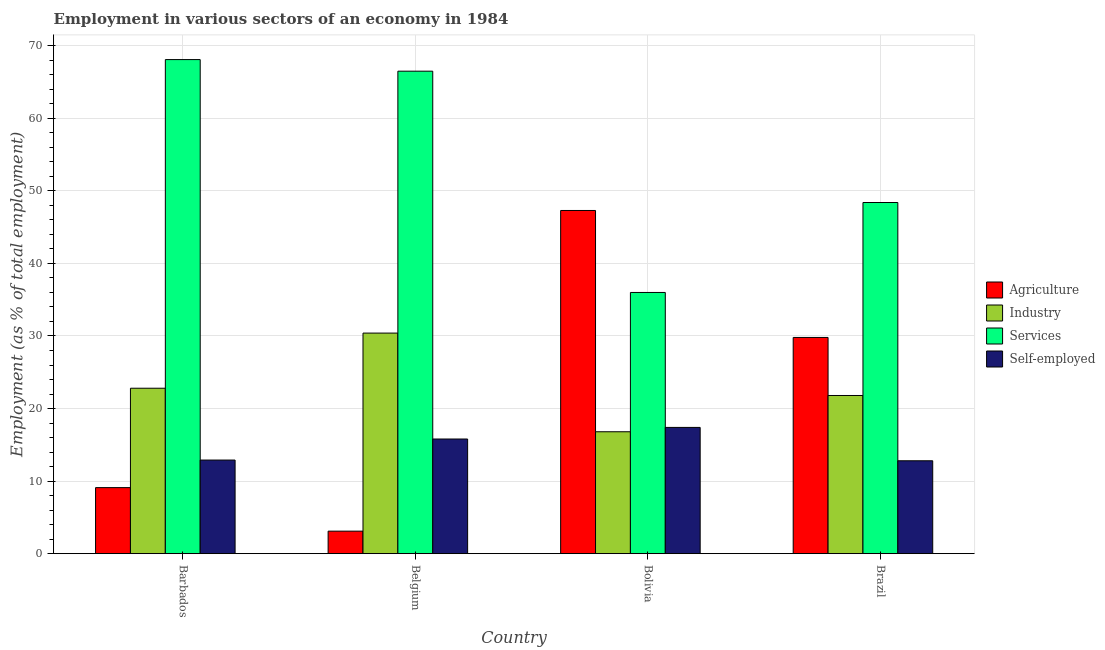How many groups of bars are there?
Give a very brief answer. 4. Are the number of bars per tick equal to the number of legend labels?
Provide a short and direct response. Yes. What is the label of the 3rd group of bars from the left?
Your answer should be very brief. Bolivia. In how many cases, is the number of bars for a given country not equal to the number of legend labels?
Make the answer very short. 0. What is the percentage of self employed workers in Bolivia?
Ensure brevity in your answer.  17.4. Across all countries, what is the maximum percentage of workers in industry?
Your answer should be compact. 30.4. In which country was the percentage of workers in agriculture minimum?
Your answer should be very brief. Belgium. What is the total percentage of workers in agriculture in the graph?
Provide a short and direct response. 89.3. What is the difference between the percentage of workers in industry in Barbados and that in Belgium?
Your answer should be very brief. -7.6. What is the difference between the percentage of workers in industry in Belgium and the percentage of workers in services in Barbados?
Give a very brief answer. -37.7. What is the average percentage of workers in agriculture per country?
Offer a very short reply. 22.32. What is the difference between the percentage of workers in agriculture and percentage of workers in services in Barbados?
Ensure brevity in your answer.  -59. In how many countries, is the percentage of self employed workers greater than 18 %?
Make the answer very short. 0. What is the ratio of the percentage of workers in industry in Bolivia to that in Brazil?
Provide a short and direct response. 0.77. Is the difference between the percentage of workers in agriculture in Bolivia and Brazil greater than the difference between the percentage of workers in industry in Bolivia and Brazil?
Offer a terse response. Yes. What is the difference between the highest and the second highest percentage of workers in agriculture?
Your response must be concise. 17.5. What is the difference between the highest and the lowest percentage of workers in industry?
Offer a terse response. 13.6. In how many countries, is the percentage of self employed workers greater than the average percentage of self employed workers taken over all countries?
Ensure brevity in your answer.  2. Is it the case that in every country, the sum of the percentage of workers in agriculture and percentage of workers in industry is greater than the sum of percentage of workers in services and percentage of self employed workers?
Offer a terse response. No. What does the 1st bar from the left in Barbados represents?
Give a very brief answer. Agriculture. What does the 1st bar from the right in Bolivia represents?
Your response must be concise. Self-employed. How many bars are there?
Offer a terse response. 16. How many countries are there in the graph?
Ensure brevity in your answer.  4. How are the legend labels stacked?
Give a very brief answer. Vertical. What is the title of the graph?
Your response must be concise. Employment in various sectors of an economy in 1984. What is the label or title of the Y-axis?
Keep it short and to the point. Employment (as % of total employment). What is the Employment (as % of total employment) of Agriculture in Barbados?
Your response must be concise. 9.1. What is the Employment (as % of total employment) in Industry in Barbados?
Ensure brevity in your answer.  22.8. What is the Employment (as % of total employment) in Services in Barbados?
Provide a short and direct response. 68.1. What is the Employment (as % of total employment) of Self-employed in Barbados?
Make the answer very short. 12.9. What is the Employment (as % of total employment) in Agriculture in Belgium?
Keep it short and to the point. 3.1. What is the Employment (as % of total employment) in Industry in Belgium?
Provide a short and direct response. 30.4. What is the Employment (as % of total employment) of Services in Belgium?
Your response must be concise. 66.5. What is the Employment (as % of total employment) of Self-employed in Belgium?
Keep it short and to the point. 15.8. What is the Employment (as % of total employment) in Agriculture in Bolivia?
Ensure brevity in your answer.  47.3. What is the Employment (as % of total employment) of Industry in Bolivia?
Provide a succinct answer. 16.8. What is the Employment (as % of total employment) of Self-employed in Bolivia?
Give a very brief answer. 17.4. What is the Employment (as % of total employment) of Agriculture in Brazil?
Offer a terse response. 29.8. What is the Employment (as % of total employment) of Industry in Brazil?
Make the answer very short. 21.8. What is the Employment (as % of total employment) of Services in Brazil?
Provide a short and direct response. 48.4. What is the Employment (as % of total employment) in Self-employed in Brazil?
Offer a terse response. 12.8. Across all countries, what is the maximum Employment (as % of total employment) in Agriculture?
Provide a succinct answer. 47.3. Across all countries, what is the maximum Employment (as % of total employment) in Industry?
Provide a short and direct response. 30.4. Across all countries, what is the maximum Employment (as % of total employment) in Services?
Offer a very short reply. 68.1. Across all countries, what is the maximum Employment (as % of total employment) in Self-employed?
Make the answer very short. 17.4. Across all countries, what is the minimum Employment (as % of total employment) in Agriculture?
Provide a succinct answer. 3.1. Across all countries, what is the minimum Employment (as % of total employment) in Industry?
Provide a succinct answer. 16.8. Across all countries, what is the minimum Employment (as % of total employment) of Services?
Offer a very short reply. 36. Across all countries, what is the minimum Employment (as % of total employment) in Self-employed?
Your answer should be very brief. 12.8. What is the total Employment (as % of total employment) of Agriculture in the graph?
Offer a terse response. 89.3. What is the total Employment (as % of total employment) in Industry in the graph?
Keep it short and to the point. 91.8. What is the total Employment (as % of total employment) of Services in the graph?
Make the answer very short. 219. What is the total Employment (as % of total employment) in Self-employed in the graph?
Your answer should be compact. 58.9. What is the difference between the Employment (as % of total employment) in Industry in Barbados and that in Belgium?
Your answer should be very brief. -7.6. What is the difference between the Employment (as % of total employment) in Self-employed in Barbados and that in Belgium?
Ensure brevity in your answer.  -2.9. What is the difference between the Employment (as % of total employment) of Agriculture in Barbados and that in Bolivia?
Your answer should be very brief. -38.2. What is the difference between the Employment (as % of total employment) of Services in Barbados and that in Bolivia?
Offer a very short reply. 32.1. What is the difference between the Employment (as % of total employment) in Agriculture in Barbados and that in Brazil?
Make the answer very short. -20.7. What is the difference between the Employment (as % of total employment) in Agriculture in Belgium and that in Bolivia?
Your answer should be compact. -44.2. What is the difference between the Employment (as % of total employment) in Industry in Belgium and that in Bolivia?
Offer a very short reply. 13.6. What is the difference between the Employment (as % of total employment) in Services in Belgium and that in Bolivia?
Make the answer very short. 30.5. What is the difference between the Employment (as % of total employment) in Self-employed in Belgium and that in Bolivia?
Make the answer very short. -1.6. What is the difference between the Employment (as % of total employment) of Agriculture in Belgium and that in Brazil?
Your response must be concise. -26.7. What is the difference between the Employment (as % of total employment) in Industry in Belgium and that in Brazil?
Your answer should be compact. 8.6. What is the difference between the Employment (as % of total employment) of Industry in Bolivia and that in Brazil?
Provide a short and direct response. -5. What is the difference between the Employment (as % of total employment) of Services in Bolivia and that in Brazil?
Ensure brevity in your answer.  -12.4. What is the difference between the Employment (as % of total employment) of Self-employed in Bolivia and that in Brazil?
Offer a terse response. 4.6. What is the difference between the Employment (as % of total employment) in Agriculture in Barbados and the Employment (as % of total employment) in Industry in Belgium?
Provide a succinct answer. -21.3. What is the difference between the Employment (as % of total employment) in Agriculture in Barbados and the Employment (as % of total employment) in Services in Belgium?
Offer a terse response. -57.4. What is the difference between the Employment (as % of total employment) of Industry in Barbados and the Employment (as % of total employment) of Services in Belgium?
Provide a succinct answer. -43.7. What is the difference between the Employment (as % of total employment) in Services in Barbados and the Employment (as % of total employment) in Self-employed in Belgium?
Give a very brief answer. 52.3. What is the difference between the Employment (as % of total employment) in Agriculture in Barbados and the Employment (as % of total employment) in Services in Bolivia?
Your answer should be very brief. -26.9. What is the difference between the Employment (as % of total employment) of Agriculture in Barbados and the Employment (as % of total employment) of Self-employed in Bolivia?
Give a very brief answer. -8.3. What is the difference between the Employment (as % of total employment) of Industry in Barbados and the Employment (as % of total employment) of Self-employed in Bolivia?
Make the answer very short. 5.4. What is the difference between the Employment (as % of total employment) of Services in Barbados and the Employment (as % of total employment) of Self-employed in Bolivia?
Your response must be concise. 50.7. What is the difference between the Employment (as % of total employment) in Agriculture in Barbados and the Employment (as % of total employment) in Industry in Brazil?
Your answer should be compact. -12.7. What is the difference between the Employment (as % of total employment) of Agriculture in Barbados and the Employment (as % of total employment) of Services in Brazil?
Your answer should be very brief. -39.3. What is the difference between the Employment (as % of total employment) in Industry in Barbados and the Employment (as % of total employment) in Services in Brazil?
Give a very brief answer. -25.6. What is the difference between the Employment (as % of total employment) of Industry in Barbados and the Employment (as % of total employment) of Self-employed in Brazil?
Your answer should be compact. 10. What is the difference between the Employment (as % of total employment) of Services in Barbados and the Employment (as % of total employment) of Self-employed in Brazil?
Keep it short and to the point. 55.3. What is the difference between the Employment (as % of total employment) in Agriculture in Belgium and the Employment (as % of total employment) in Industry in Bolivia?
Your answer should be very brief. -13.7. What is the difference between the Employment (as % of total employment) of Agriculture in Belgium and the Employment (as % of total employment) of Services in Bolivia?
Offer a terse response. -32.9. What is the difference between the Employment (as % of total employment) in Agriculture in Belgium and the Employment (as % of total employment) in Self-employed in Bolivia?
Provide a short and direct response. -14.3. What is the difference between the Employment (as % of total employment) of Industry in Belgium and the Employment (as % of total employment) of Self-employed in Bolivia?
Ensure brevity in your answer.  13. What is the difference between the Employment (as % of total employment) in Services in Belgium and the Employment (as % of total employment) in Self-employed in Bolivia?
Offer a terse response. 49.1. What is the difference between the Employment (as % of total employment) of Agriculture in Belgium and the Employment (as % of total employment) of Industry in Brazil?
Keep it short and to the point. -18.7. What is the difference between the Employment (as % of total employment) in Agriculture in Belgium and the Employment (as % of total employment) in Services in Brazil?
Offer a terse response. -45.3. What is the difference between the Employment (as % of total employment) in Agriculture in Belgium and the Employment (as % of total employment) in Self-employed in Brazil?
Offer a terse response. -9.7. What is the difference between the Employment (as % of total employment) in Industry in Belgium and the Employment (as % of total employment) in Self-employed in Brazil?
Give a very brief answer. 17.6. What is the difference between the Employment (as % of total employment) of Services in Belgium and the Employment (as % of total employment) of Self-employed in Brazil?
Ensure brevity in your answer.  53.7. What is the difference between the Employment (as % of total employment) in Agriculture in Bolivia and the Employment (as % of total employment) in Services in Brazil?
Provide a short and direct response. -1.1. What is the difference between the Employment (as % of total employment) in Agriculture in Bolivia and the Employment (as % of total employment) in Self-employed in Brazil?
Keep it short and to the point. 34.5. What is the difference between the Employment (as % of total employment) in Industry in Bolivia and the Employment (as % of total employment) in Services in Brazil?
Keep it short and to the point. -31.6. What is the difference between the Employment (as % of total employment) of Services in Bolivia and the Employment (as % of total employment) of Self-employed in Brazil?
Offer a very short reply. 23.2. What is the average Employment (as % of total employment) in Agriculture per country?
Your answer should be compact. 22.32. What is the average Employment (as % of total employment) in Industry per country?
Your answer should be very brief. 22.95. What is the average Employment (as % of total employment) of Services per country?
Your answer should be compact. 54.75. What is the average Employment (as % of total employment) in Self-employed per country?
Ensure brevity in your answer.  14.72. What is the difference between the Employment (as % of total employment) of Agriculture and Employment (as % of total employment) of Industry in Barbados?
Your answer should be very brief. -13.7. What is the difference between the Employment (as % of total employment) of Agriculture and Employment (as % of total employment) of Services in Barbados?
Your answer should be very brief. -59. What is the difference between the Employment (as % of total employment) in Industry and Employment (as % of total employment) in Services in Barbados?
Provide a succinct answer. -45.3. What is the difference between the Employment (as % of total employment) of Services and Employment (as % of total employment) of Self-employed in Barbados?
Keep it short and to the point. 55.2. What is the difference between the Employment (as % of total employment) in Agriculture and Employment (as % of total employment) in Industry in Belgium?
Make the answer very short. -27.3. What is the difference between the Employment (as % of total employment) of Agriculture and Employment (as % of total employment) of Services in Belgium?
Offer a very short reply. -63.4. What is the difference between the Employment (as % of total employment) in Industry and Employment (as % of total employment) in Services in Belgium?
Give a very brief answer. -36.1. What is the difference between the Employment (as % of total employment) of Industry and Employment (as % of total employment) of Self-employed in Belgium?
Your answer should be compact. 14.6. What is the difference between the Employment (as % of total employment) in Services and Employment (as % of total employment) in Self-employed in Belgium?
Provide a succinct answer. 50.7. What is the difference between the Employment (as % of total employment) of Agriculture and Employment (as % of total employment) of Industry in Bolivia?
Your answer should be very brief. 30.5. What is the difference between the Employment (as % of total employment) of Agriculture and Employment (as % of total employment) of Self-employed in Bolivia?
Keep it short and to the point. 29.9. What is the difference between the Employment (as % of total employment) of Industry and Employment (as % of total employment) of Services in Bolivia?
Your answer should be very brief. -19.2. What is the difference between the Employment (as % of total employment) in Services and Employment (as % of total employment) in Self-employed in Bolivia?
Provide a succinct answer. 18.6. What is the difference between the Employment (as % of total employment) in Agriculture and Employment (as % of total employment) in Services in Brazil?
Offer a very short reply. -18.6. What is the difference between the Employment (as % of total employment) of Agriculture and Employment (as % of total employment) of Self-employed in Brazil?
Offer a terse response. 17. What is the difference between the Employment (as % of total employment) in Industry and Employment (as % of total employment) in Services in Brazil?
Provide a short and direct response. -26.6. What is the difference between the Employment (as % of total employment) of Services and Employment (as % of total employment) of Self-employed in Brazil?
Provide a short and direct response. 35.6. What is the ratio of the Employment (as % of total employment) of Agriculture in Barbados to that in Belgium?
Your answer should be compact. 2.94. What is the ratio of the Employment (as % of total employment) in Industry in Barbados to that in Belgium?
Your response must be concise. 0.75. What is the ratio of the Employment (as % of total employment) in Services in Barbados to that in Belgium?
Offer a very short reply. 1.02. What is the ratio of the Employment (as % of total employment) of Self-employed in Barbados to that in Belgium?
Give a very brief answer. 0.82. What is the ratio of the Employment (as % of total employment) of Agriculture in Barbados to that in Bolivia?
Your answer should be very brief. 0.19. What is the ratio of the Employment (as % of total employment) of Industry in Barbados to that in Bolivia?
Provide a succinct answer. 1.36. What is the ratio of the Employment (as % of total employment) of Services in Barbados to that in Bolivia?
Provide a short and direct response. 1.89. What is the ratio of the Employment (as % of total employment) in Self-employed in Barbados to that in Bolivia?
Offer a terse response. 0.74. What is the ratio of the Employment (as % of total employment) in Agriculture in Barbados to that in Brazil?
Offer a terse response. 0.31. What is the ratio of the Employment (as % of total employment) of Industry in Barbados to that in Brazil?
Offer a very short reply. 1.05. What is the ratio of the Employment (as % of total employment) of Services in Barbados to that in Brazil?
Your response must be concise. 1.41. What is the ratio of the Employment (as % of total employment) in Agriculture in Belgium to that in Bolivia?
Provide a succinct answer. 0.07. What is the ratio of the Employment (as % of total employment) in Industry in Belgium to that in Bolivia?
Provide a succinct answer. 1.81. What is the ratio of the Employment (as % of total employment) of Services in Belgium to that in Bolivia?
Offer a very short reply. 1.85. What is the ratio of the Employment (as % of total employment) in Self-employed in Belgium to that in Bolivia?
Keep it short and to the point. 0.91. What is the ratio of the Employment (as % of total employment) of Agriculture in Belgium to that in Brazil?
Offer a terse response. 0.1. What is the ratio of the Employment (as % of total employment) of Industry in Belgium to that in Brazil?
Provide a short and direct response. 1.39. What is the ratio of the Employment (as % of total employment) of Services in Belgium to that in Brazil?
Your response must be concise. 1.37. What is the ratio of the Employment (as % of total employment) in Self-employed in Belgium to that in Brazil?
Make the answer very short. 1.23. What is the ratio of the Employment (as % of total employment) in Agriculture in Bolivia to that in Brazil?
Offer a very short reply. 1.59. What is the ratio of the Employment (as % of total employment) in Industry in Bolivia to that in Brazil?
Keep it short and to the point. 0.77. What is the ratio of the Employment (as % of total employment) of Services in Bolivia to that in Brazil?
Your answer should be very brief. 0.74. What is the ratio of the Employment (as % of total employment) of Self-employed in Bolivia to that in Brazil?
Provide a succinct answer. 1.36. What is the difference between the highest and the second highest Employment (as % of total employment) of Agriculture?
Provide a succinct answer. 17.5. What is the difference between the highest and the second highest Employment (as % of total employment) of Services?
Your response must be concise. 1.6. What is the difference between the highest and the second highest Employment (as % of total employment) of Self-employed?
Provide a succinct answer. 1.6. What is the difference between the highest and the lowest Employment (as % of total employment) in Agriculture?
Your response must be concise. 44.2. What is the difference between the highest and the lowest Employment (as % of total employment) in Services?
Ensure brevity in your answer.  32.1. What is the difference between the highest and the lowest Employment (as % of total employment) of Self-employed?
Provide a short and direct response. 4.6. 